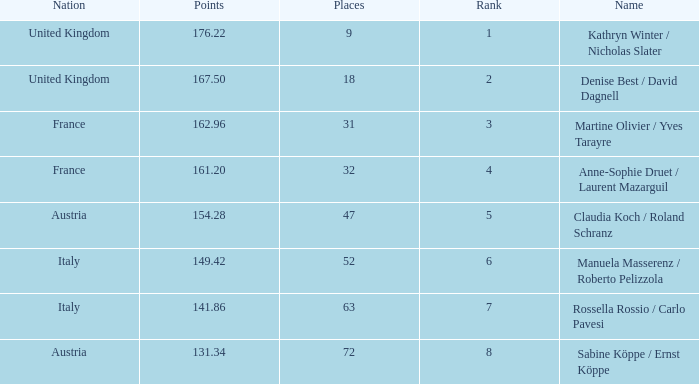Who has points larger than 167.5? Kathryn Winter / Nicholas Slater. 